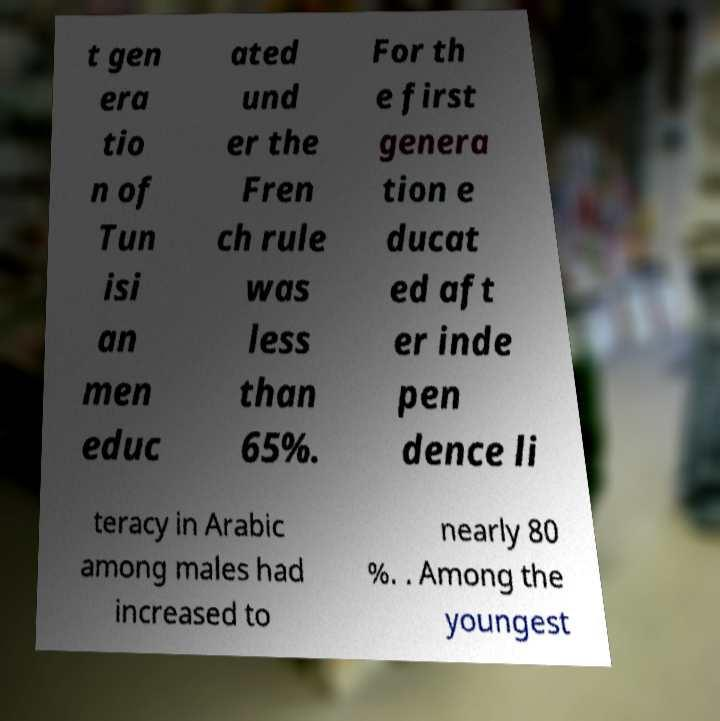Can you read and provide the text displayed in the image?This photo seems to have some interesting text. Can you extract and type it out for me? t gen era tio n of Tun isi an men educ ated und er the Fren ch rule was less than 65%. For th e first genera tion e ducat ed aft er inde pen dence li teracy in Arabic among males had increased to nearly 80 %. . Among the youngest 